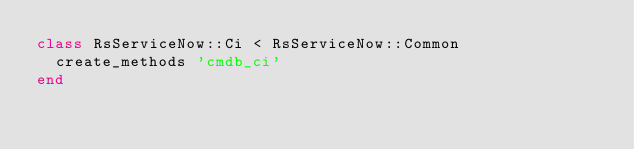Convert code to text. <code><loc_0><loc_0><loc_500><loc_500><_Ruby_>class RsServiceNow::Ci < RsServiceNow::Common
  create_methods 'cmdb_ci'
end</code> 